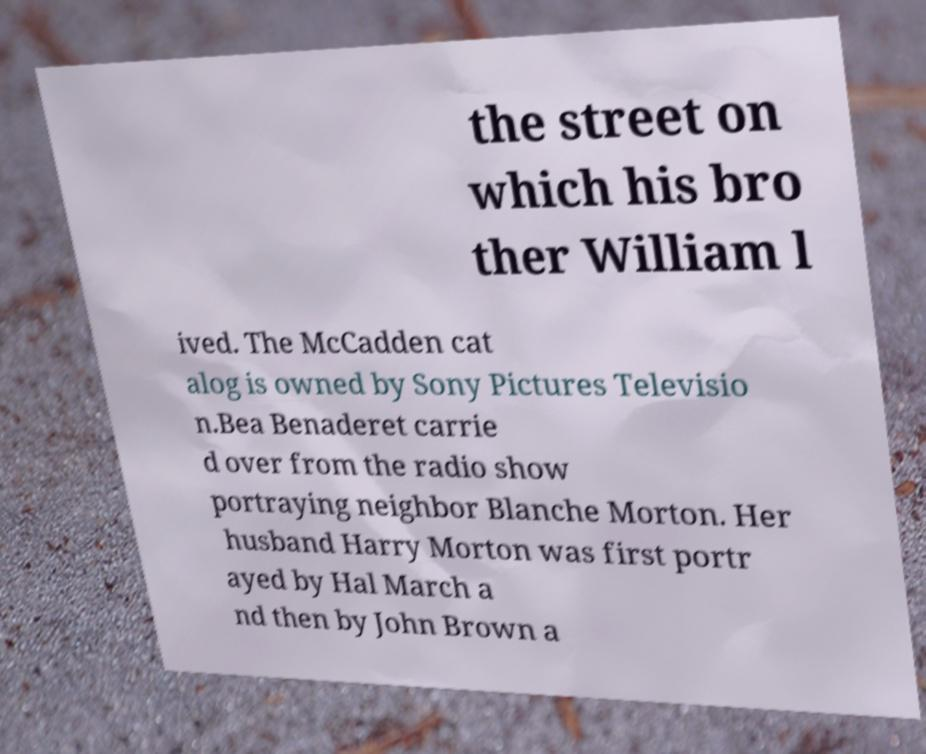Can you accurately transcribe the text from the provided image for me? the street on which his bro ther William l ived. The McCadden cat alog is owned by Sony Pictures Televisio n.Bea Benaderet carrie d over from the radio show portraying neighbor Blanche Morton. Her husband Harry Morton was first portr ayed by Hal March a nd then by John Brown a 